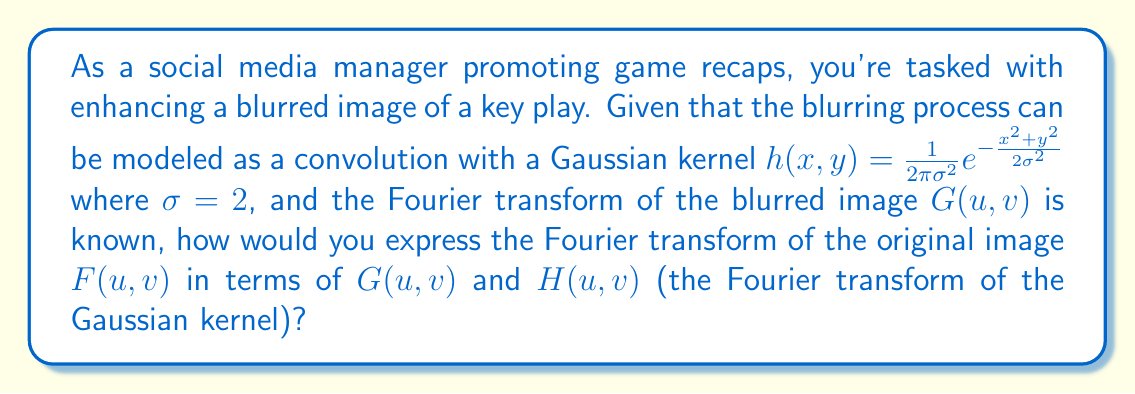Help me with this question. To solve this problem, we'll follow these steps:

1) In image processing, blurring can be modeled as a convolution operation:

   $g(x,y) = f(x,y) * h(x,y)$

   where $g$ is the blurred image, $f$ is the original image, and $h$ is the blurring kernel.

2) In the Fourier domain, convolution becomes multiplication:

   $G(u,v) = F(u,v) \cdot H(u,v)$

3) To recover the original image, we need to perform deconvolution. In the Fourier domain, this is equivalent to division:

   $F(u,v) = \frac{G(u,v)}{H(u,v)}$

4) The Fourier transform of a 2D Gaussian function with standard deviation $\sigma$ is:

   $H(u,v) = e^{-2\pi^2\sigma^2(u^2+v^2)}$

5) Substituting $\sigma = 2$ into this expression:

   $H(u,v) = e^{-8\pi^2(u^2+v^2)}$

6) Therefore, the Fourier transform of the original image can be expressed as:

   $F(u,v) = \frac{G(u,v)}{e^{-8\pi^2(u^2+v^2)}}$

This expression allows us to recover the Fourier transform of the original image, which can then be inverse transformed to obtain the enhanced image for the game recap.
Answer: $F(u,v) = \frac{G(u,v)}{e^{-8\pi^2(u^2+v^2)}}$ 